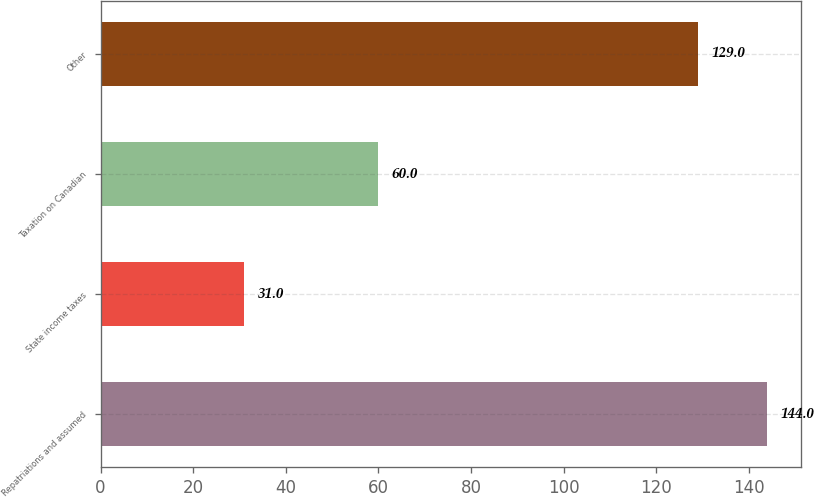<chart> <loc_0><loc_0><loc_500><loc_500><bar_chart><fcel>Repatriations and assumed<fcel>State income taxes<fcel>Taxation on Canadian<fcel>Other<nl><fcel>144<fcel>31<fcel>60<fcel>129<nl></chart> 